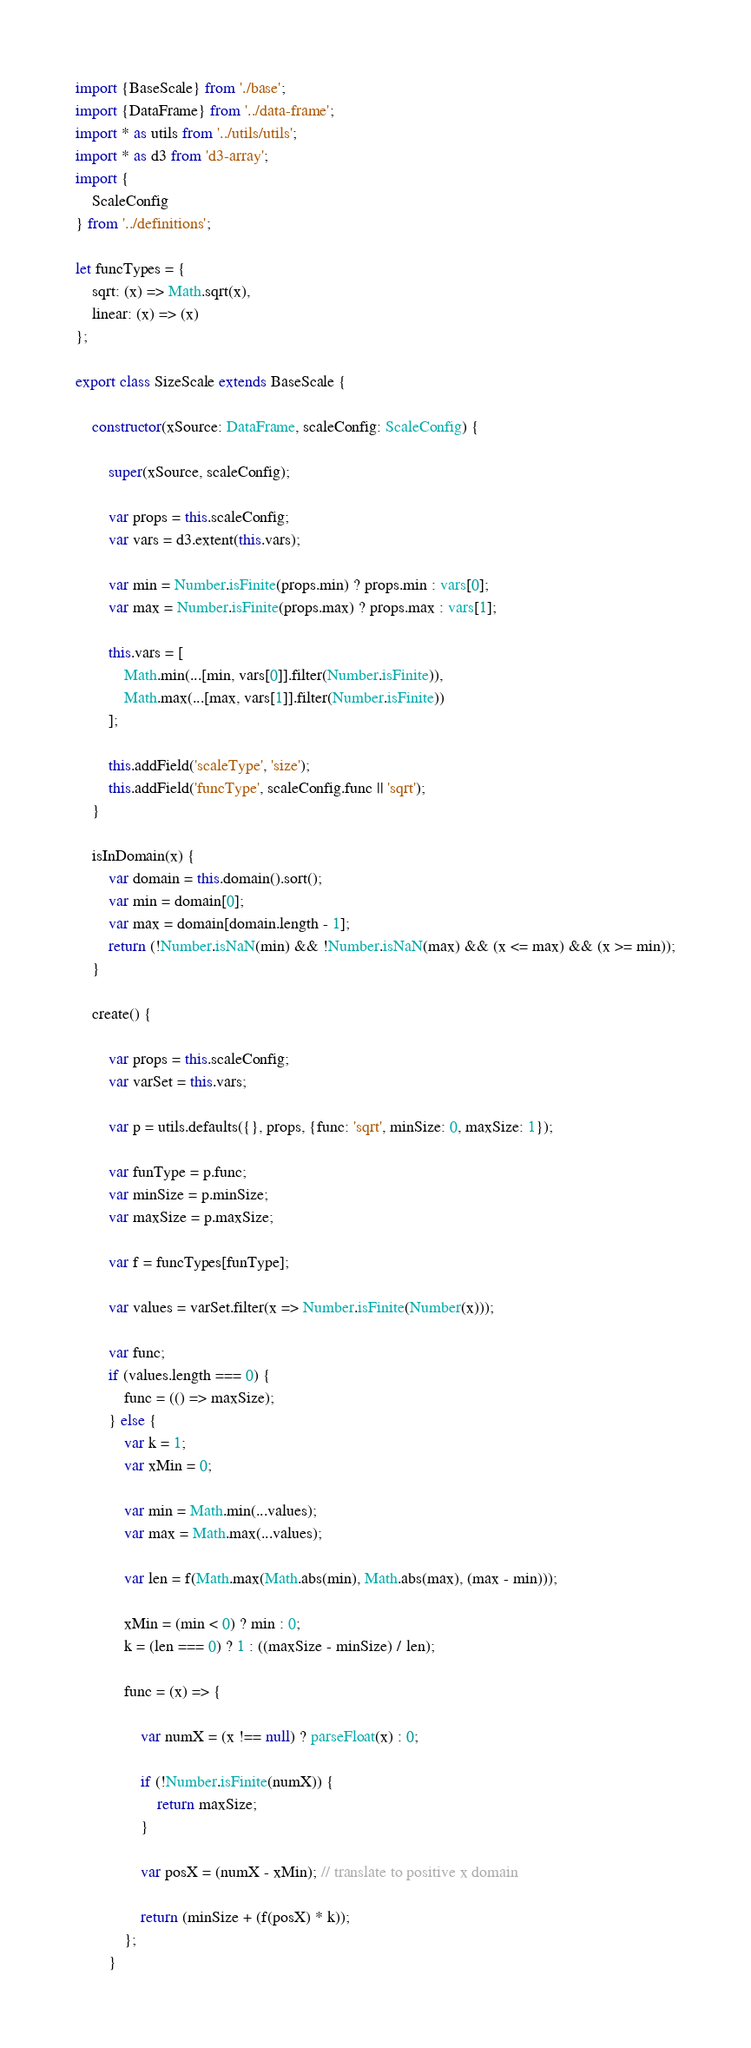<code> <loc_0><loc_0><loc_500><loc_500><_TypeScript_>import {BaseScale} from './base';
import {DataFrame} from '../data-frame';
import * as utils from '../utils/utils';
import * as d3 from 'd3-array';
import {
    ScaleConfig
} from '../definitions';

let funcTypes = {
    sqrt: (x) => Math.sqrt(x),
    linear: (x) => (x)
};

export class SizeScale extends BaseScale {

    constructor(xSource: DataFrame, scaleConfig: ScaleConfig) {

        super(xSource, scaleConfig);

        var props = this.scaleConfig;
        var vars = d3.extent(this.vars);

        var min = Number.isFinite(props.min) ? props.min : vars[0];
        var max = Number.isFinite(props.max) ? props.max : vars[1];

        this.vars = [
            Math.min(...[min, vars[0]].filter(Number.isFinite)),
            Math.max(...[max, vars[1]].filter(Number.isFinite))
        ];

        this.addField('scaleType', 'size');
        this.addField('funcType', scaleConfig.func || 'sqrt');
    }

    isInDomain(x) {
        var domain = this.domain().sort();
        var min = domain[0];
        var max = domain[domain.length - 1];
        return (!Number.isNaN(min) && !Number.isNaN(max) && (x <= max) && (x >= min));
    }

    create() {

        var props = this.scaleConfig;
        var varSet = this.vars;

        var p = utils.defaults({}, props, {func: 'sqrt', minSize: 0, maxSize: 1});

        var funType = p.func;
        var minSize = p.minSize;
        var maxSize = p.maxSize;

        var f = funcTypes[funType];

        var values = varSet.filter(x => Number.isFinite(Number(x)));

        var func;
        if (values.length === 0) {
            func = (() => maxSize);
        } else {
            var k = 1;
            var xMin = 0;

            var min = Math.min(...values);
            var max = Math.max(...values);

            var len = f(Math.max(Math.abs(min), Math.abs(max), (max - min)));

            xMin = (min < 0) ? min : 0;
            k = (len === 0) ? 1 : ((maxSize - minSize) / len);

            func = (x) => {

                var numX = (x !== null) ? parseFloat(x) : 0;

                if (!Number.isFinite(numX)) {
                    return maxSize;
                }

                var posX = (numX - xMin); // translate to positive x domain

                return (minSize + (f(posX) * k));
            };
        }
</code> 